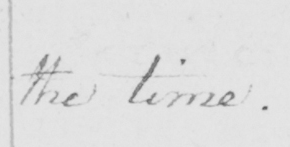What is written in this line of handwriting? the time. 